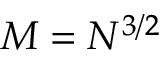<formula> <loc_0><loc_0><loc_500><loc_500>M = N ^ { 3 / 2 }</formula> 